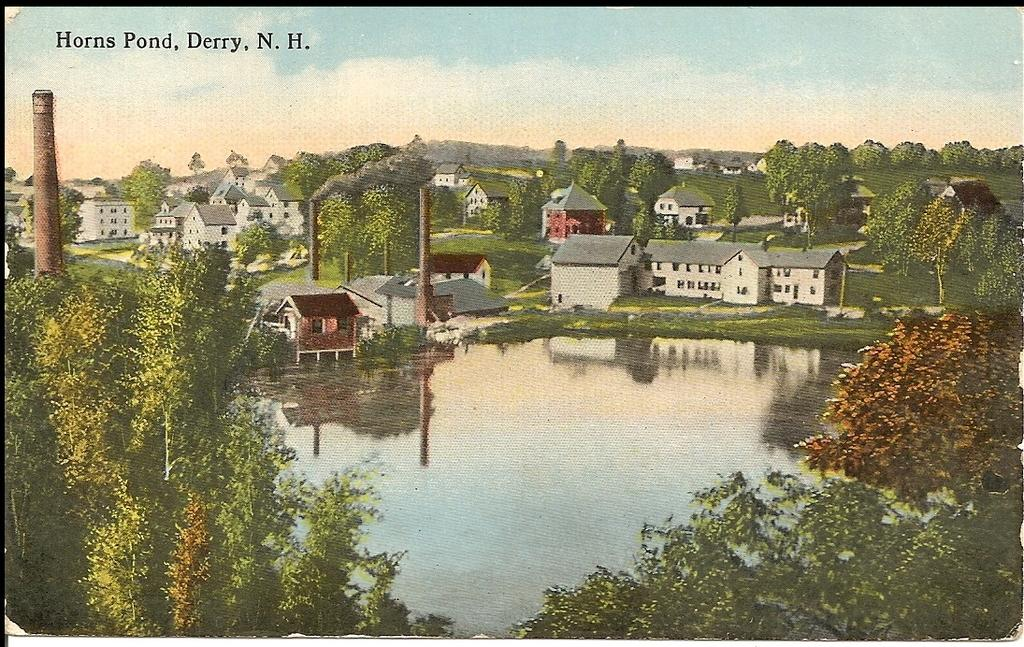What is the main subject of the image? There is a painting in the image. What is depicted in the painting? The painting depicts a pond of water. What can be seen around the pond in the painting? There are trees and houses around the pond in the painting. What is unusual about the pond in the painting? There is grass on the surface of the pond in the painting. How does the tongue of the person in the image affect the motion of the painting? There is no person in the image, and therefore no tongue or motion related to the painting. 